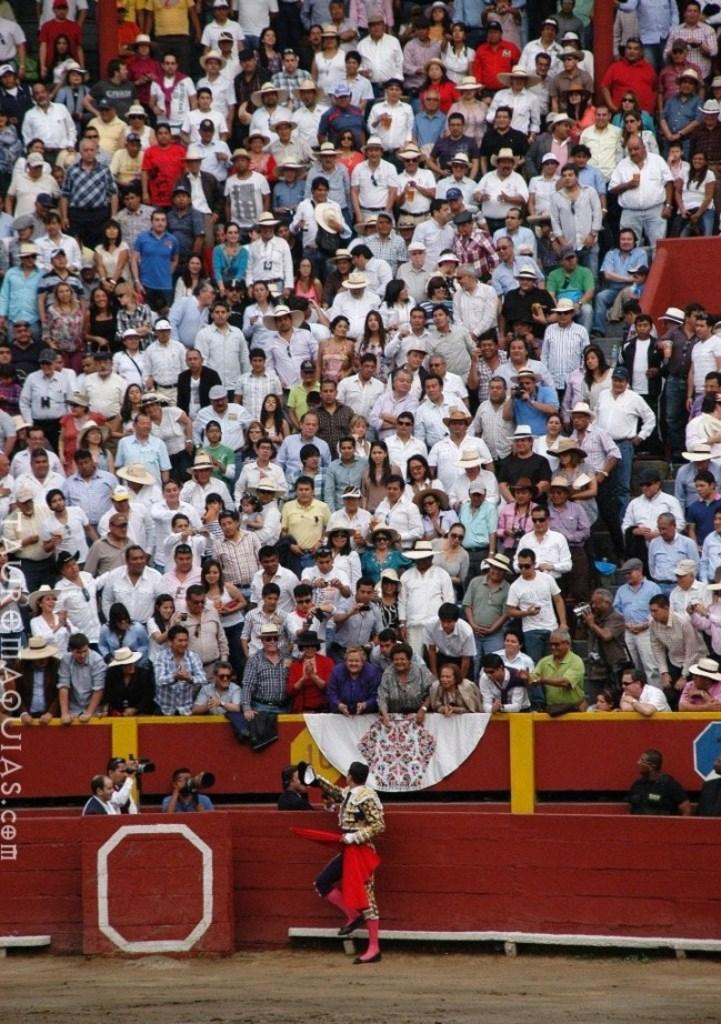What is the main subject at the bottom of the image? There is a person on the ground at the bottom of the image. Who else is present at the bottom of the image? There are cameramen at the bottom of the image. What can be seen in the background of the image? There is a crowd visible in the background of the image. How many apples are being held by the person at the bottom of the image? There are no apples visible in the image; the person is not holding any apples. 